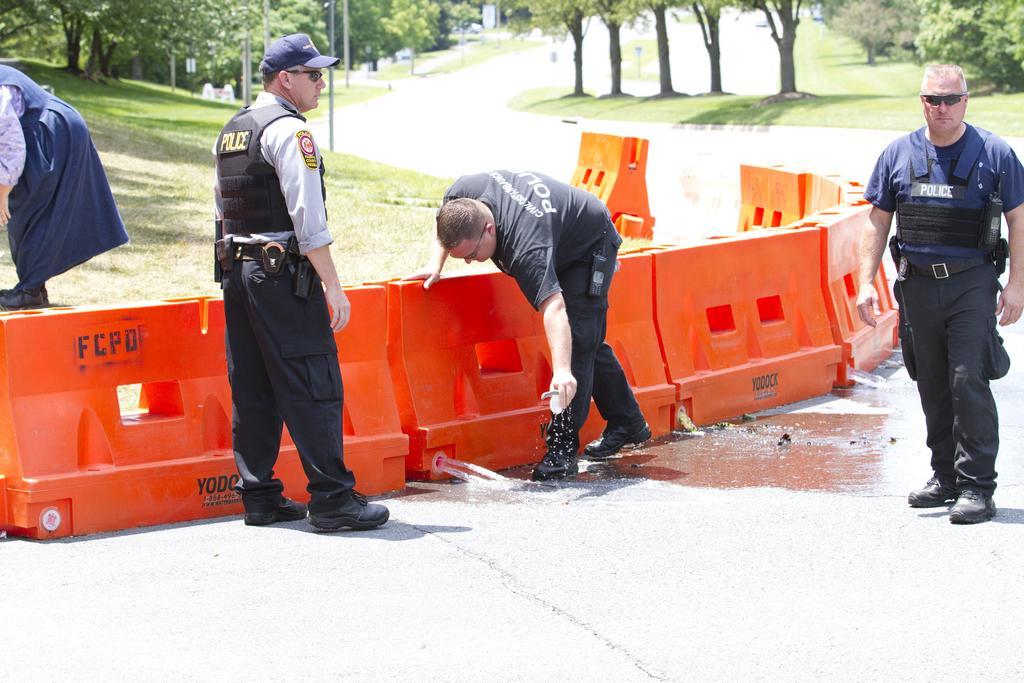Could you give a brief overview of what you see in this image? This image is taken outdoors. At the bottom of the image there is a road. In the background there are many trees and a few plants with leaves, stems and branches. There are a few poles and there is a ground with grass on it. In the middle of the image there are a few temporary fencing blocks on the road. On the left side of the image a person is standing on the ground and a man is standing on the road. On the right side of the image a man is walking on the road. In the middle of the image a man is standing and he is holding an object in his hand. 